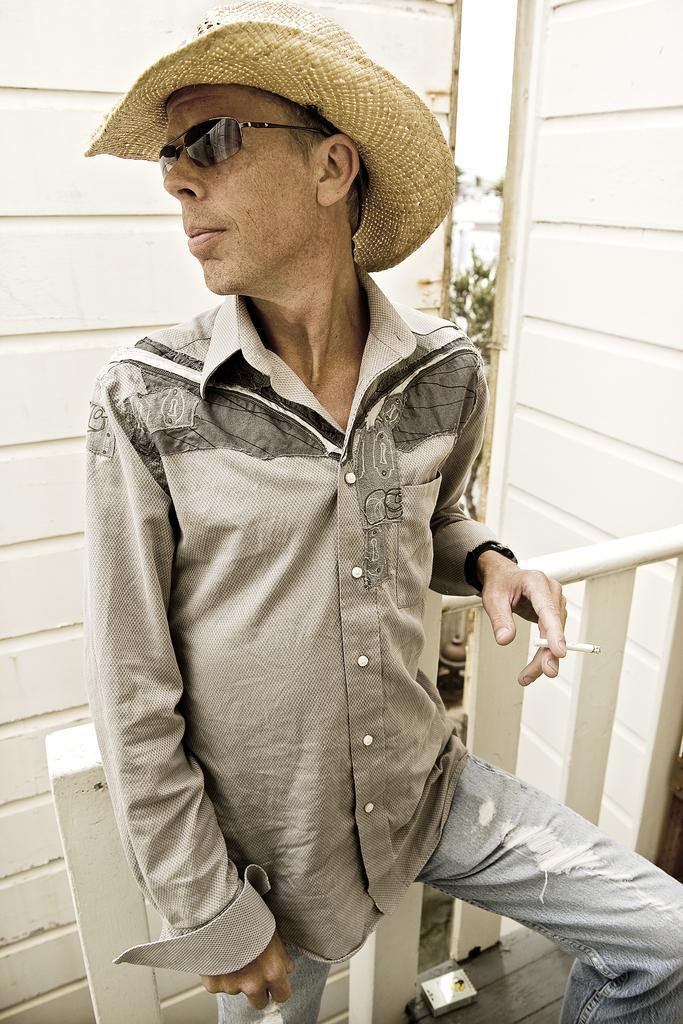In one or two sentences, can you explain what this image depicts? In this image we can able to see a person is standing with a cigarette in his hands, wearing glasses and a hat, a box is placed on the ground, behind him there is a wooden wall, also we can see some plants. 